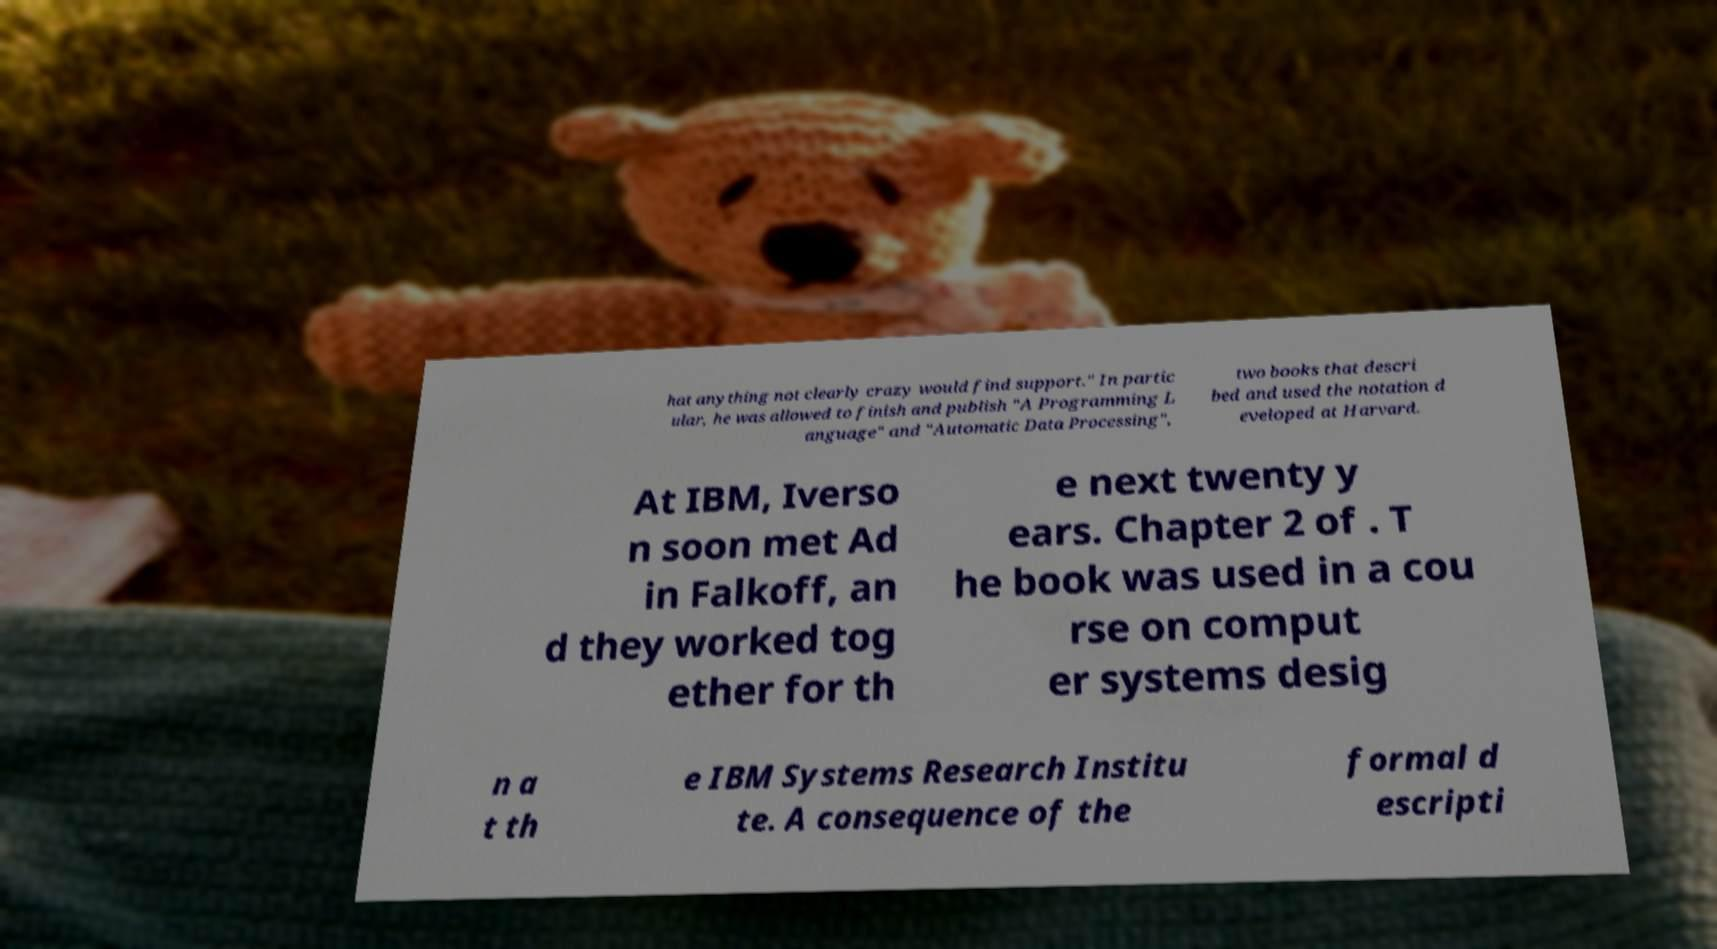Could you extract and type out the text from this image? hat anything not clearly crazy would find support." In partic ular, he was allowed to finish and publish "A Programming L anguage" and "Automatic Data Processing", two books that descri bed and used the notation d eveloped at Harvard. At IBM, Iverso n soon met Ad in Falkoff, an d they worked tog ether for th e next twenty y ears. Chapter 2 of . T he book was used in a cou rse on comput er systems desig n a t th e IBM Systems Research Institu te. A consequence of the formal d escripti 